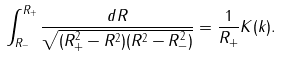<formula> <loc_0><loc_0><loc_500><loc_500>\int ^ { R _ { + } } _ { R _ { - } } \frac { d R } { \sqrt { ( R ^ { 2 } _ { + } - R ^ { 2 } ) ( R ^ { 2 } - R _ { - } ^ { 2 } ) } } = \frac { 1 } { R _ { + } } K ( k ) .</formula> 